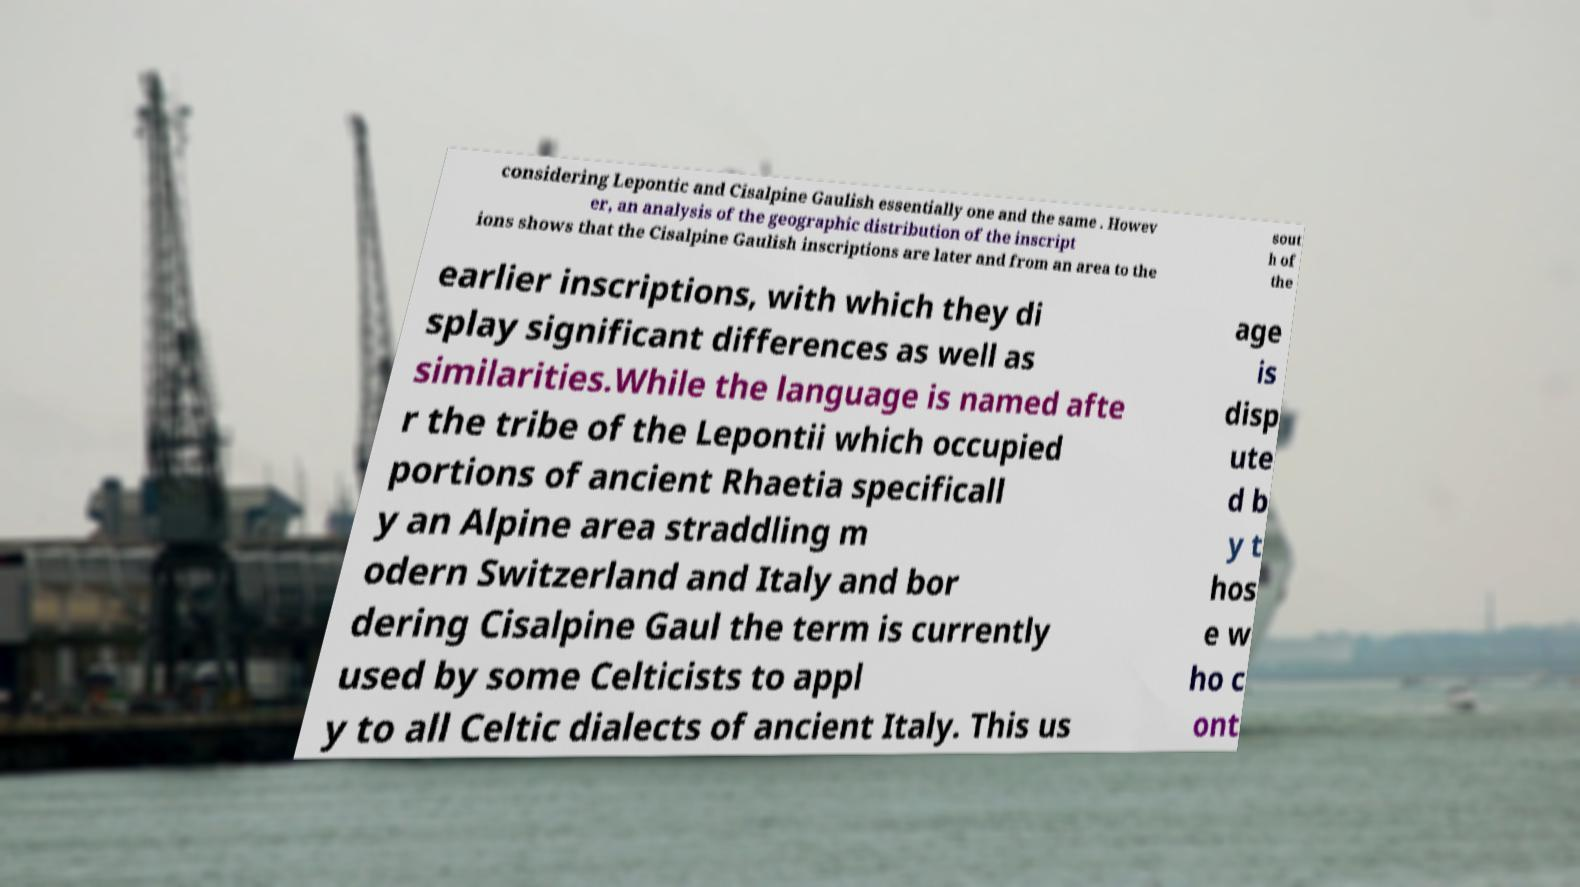There's text embedded in this image that I need extracted. Can you transcribe it verbatim? considering Lepontic and Cisalpine Gaulish essentially one and the same . Howev er, an analysis of the geographic distribution of the inscript ions shows that the Cisalpine Gaulish inscriptions are later and from an area to the sout h of the earlier inscriptions, with which they di splay significant differences as well as similarities.While the language is named afte r the tribe of the Lepontii which occupied portions of ancient Rhaetia specificall y an Alpine area straddling m odern Switzerland and Italy and bor dering Cisalpine Gaul the term is currently used by some Celticists to appl y to all Celtic dialects of ancient Italy. This us age is disp ute d b y t hos e w ho c ont 